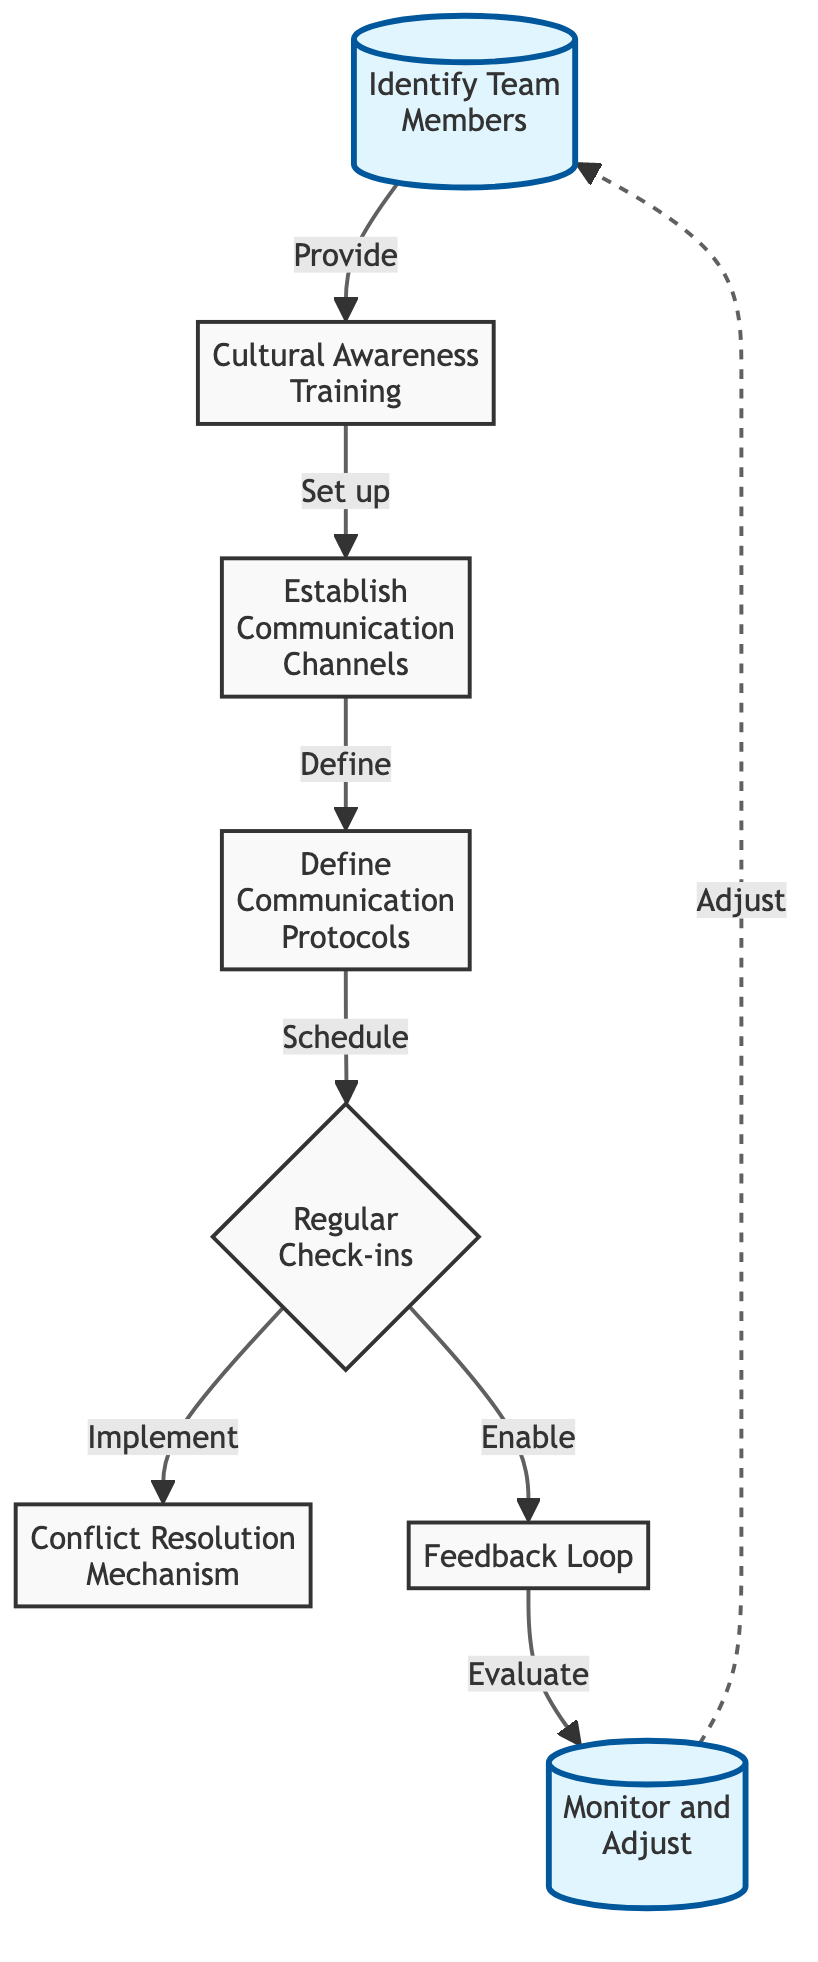What is the first step in the workflow? The first step in the workflow is represented by node 1, which states "Identify Team Members." This is the starting point of the diagram and indicates the initial action taken.
Answer: Identify Team Members How many main nodes are in the workflow? The diagram consists of a total of eight main nodes, counted from 1 to 8 inclusive, as each one represents a key component of the communication strategy.
Answer: 8 What is the relationship between "Cultural Awareness Training" and "Establish Communication Channels"? "Cultural Awareness Training" is the second node (node 2), which has a direct connection and flow to "Establish Communication Channels" (node 3), indicating that the training sets up the communication channels.
Answer: Set up What follows the "Regular Check-ins" step? The "Regular Check-ins" node (node 5) leads to two actions: it connects to "Conflict Resolution Mechanism" (node 6) and "Feedback Loop" (node 7), indicating that both are implemented after the check-ins.
Answer: Conflict Resolution Mechanism and Feedback Loop What role does the "Feedback Loop" play in the workflow? The "Feedback Loop" serves as a mechanism for evaluation; it connects to "Monitor and Adjust" (node 8), which indicates its function in assessing the workflow's effectiveness and leading to adjustments in the process.
Answer: Evaluate How does the workflow indicate the cyclical nature of the process? The diagram shows a dashed line returning from "Monitor and Adjust" (node 8) back to "Identify Team Members" (node 1), demonstrating that after adjustments, the process loops back to the beginning, showcasing the iterative aspect of the workflow.
Answer: Adjust What is the last step in the diagram? The last step in the diagram is represented by node 8, which is labeled "Monitor and Adjust." This indicates the final action in the workflow before it potentially cycles back to the start.
Answer: Monitor and Adjust What color indicates active nodes in the diagram? The active nodes are indicated in a light blue color, which stands out from the default gray background color of the other nodes in the diagram, emphasizing their significance in the workflow.
Answer: Light blue 